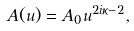<formula> <loc_0><loc_0><loc_500><loc_500>A ( u ) = A _ { 0 } u ^ { 2 i \kappa - 2 } ,</formula> 